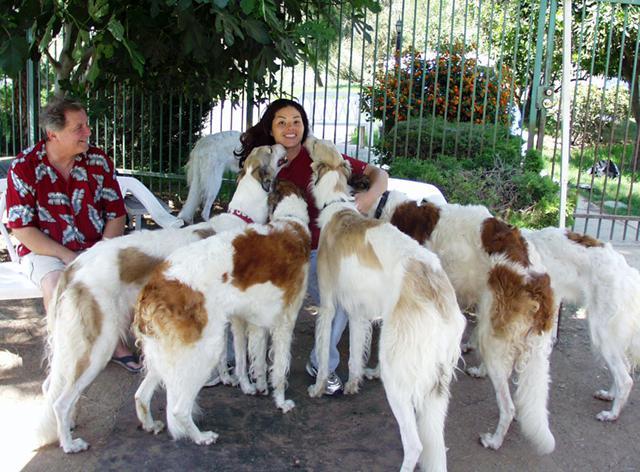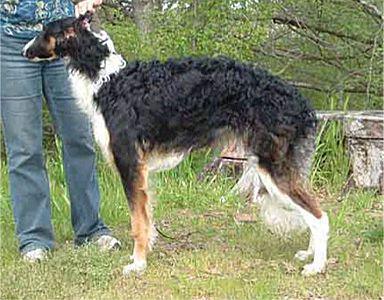The first image is the image on the left, the second image is the image on the right. Examine the images to the left and right. Is the description "An image contains no more than two hound dogs." accurate? Answer yes or no. Yes. 